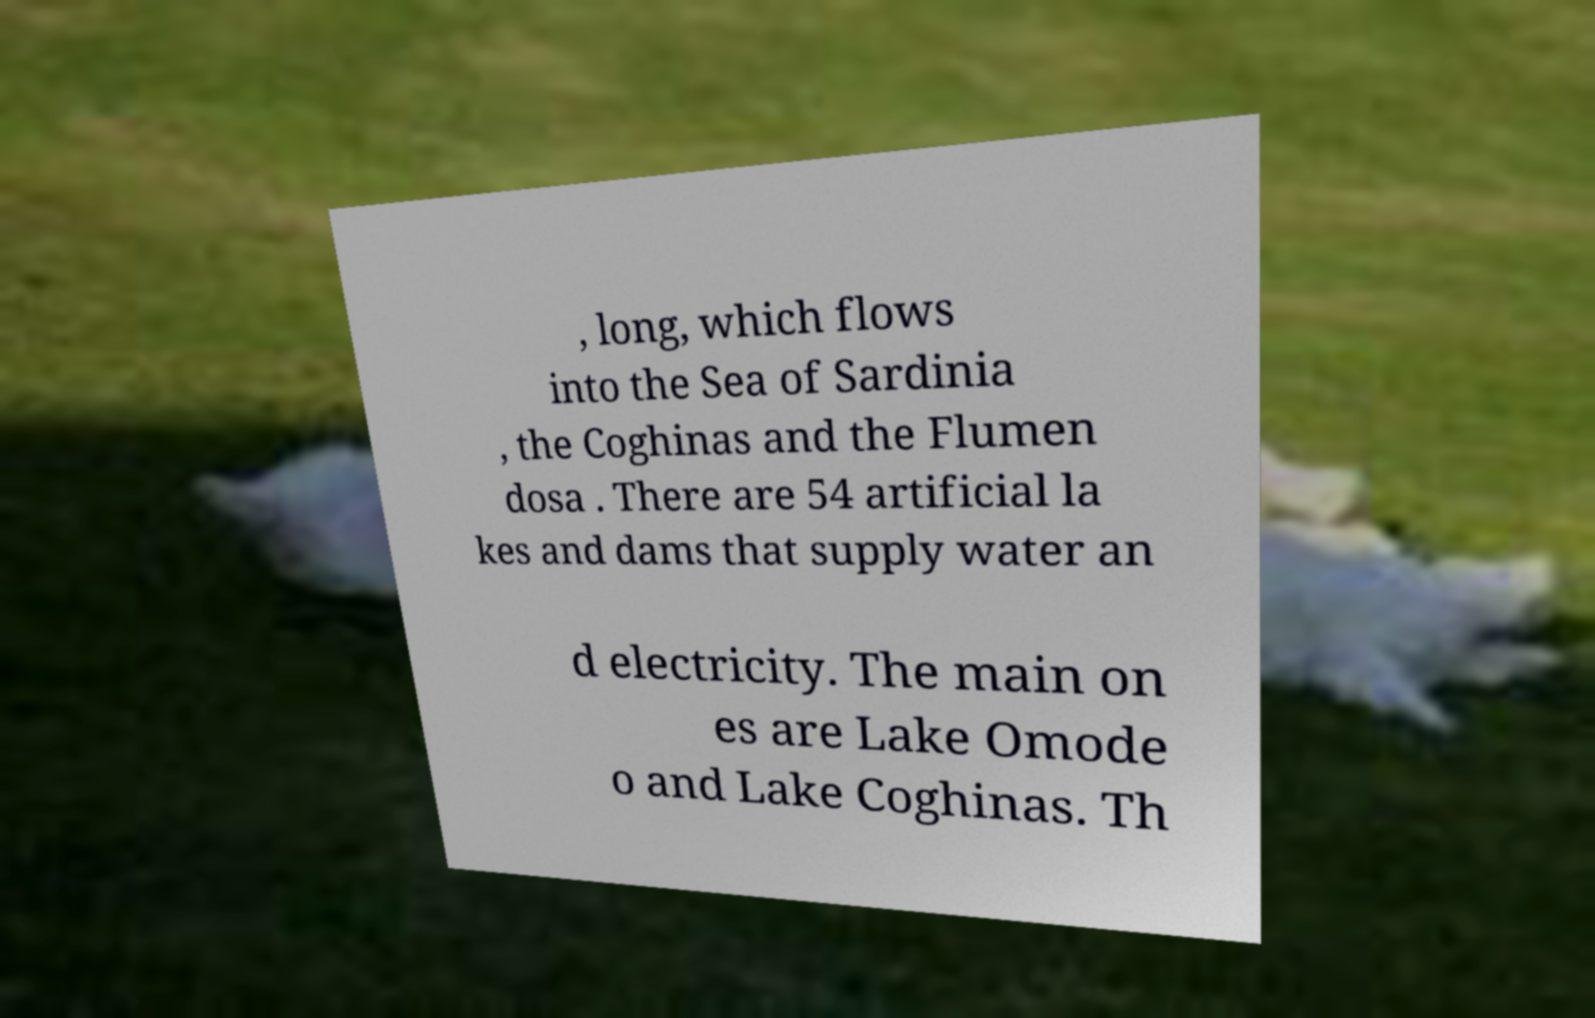Please identify and transcribe the text found in this image. , long, which flows into the Sea of Sardinia , the Coghinas and the Flumen dosa . There are 54 artificial la kes and dams that supply water an d electricity. The main on es are Lake Omode o and Lake Coghinas. Th 